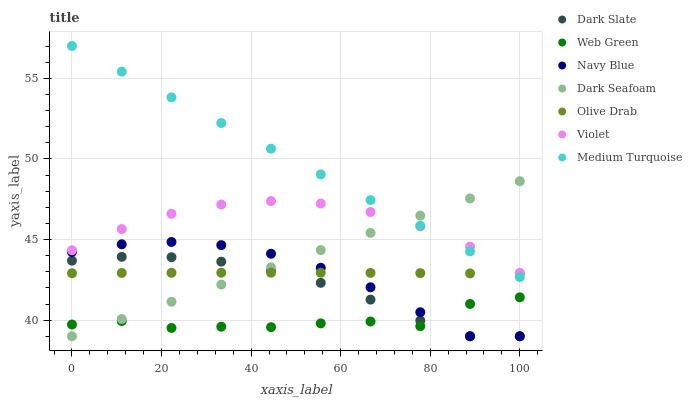Does Web Green have the minimum area under the curve?
Answer yes or no. Yes. Does Medium Turquoise have the maximum area under the curve?
Answer yes or no. Yes. Does Dark Slate have the minimum area under the curve?
Answer yes or no. No. Does Dark Slate have the maximum area under the curve?
Answer yes or no. No. Is Medium Turquoise the smoothest?
Answer yes or no. Yes. Is Web Green the roughest?
Answer yes or no. Yes. Is Dark Slate the smoothest?
Answer yes or no. No. Is Dark Slate the roughest?
Answer yes or no. No. Does Navy Blue have the lowest value?
Answer yes or no. Yes. Does Web Green have the lowest value?
Answer yes or no. No. Does Medium Turquoise have the highest value?
Answer yes or no. Yes. Does Dark Slate have the highest value?
Answer yes or no. No. Is Dark Slate less than Medium Turquoise?
Answer yes or no. Yes. Is Violet greater than Navy Blue?
Answer yes or no. Yes. Does Dark Slate intersect Olive Drab?
Answer yes or no. Yes. Is Dark Slate less than Olive Drab?
Answer yes or no. No. Is Dark Slate greater than Olive Drab?
Answer yes or no. No. Does Dark Slate intersect Medium Turquoise?
Answer yes or no. No. 